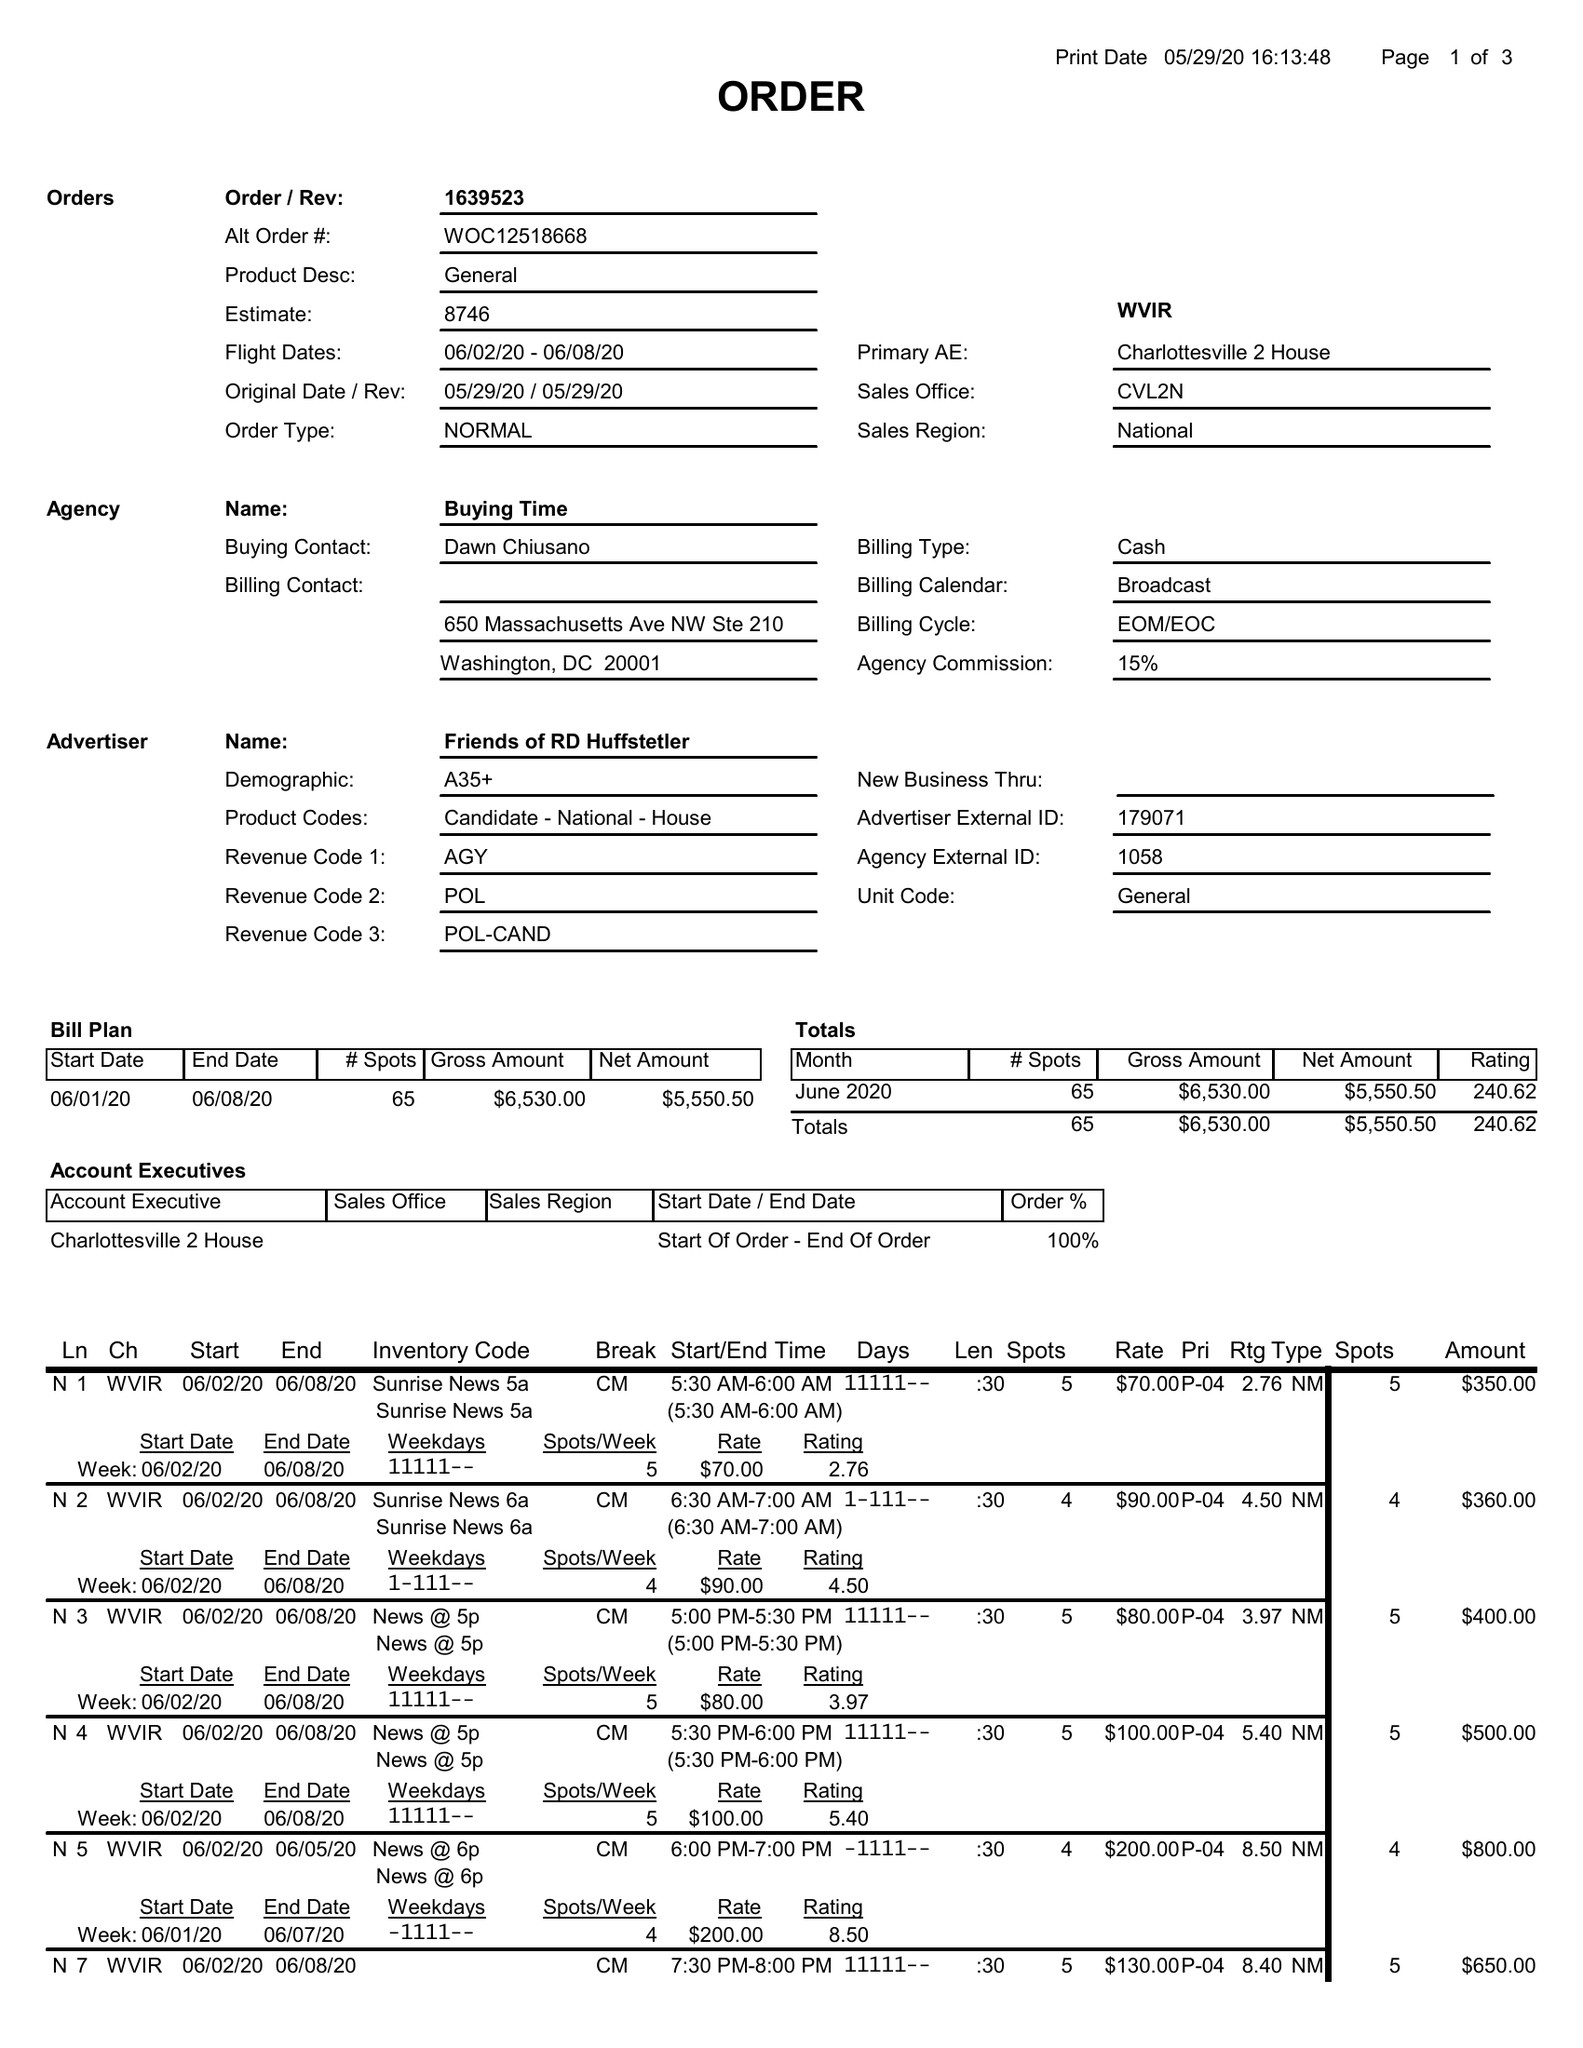What is the value for the advertiser?
Answer the question using a single word or phrase. FRIENDS OF RD HUFFSTETLER 